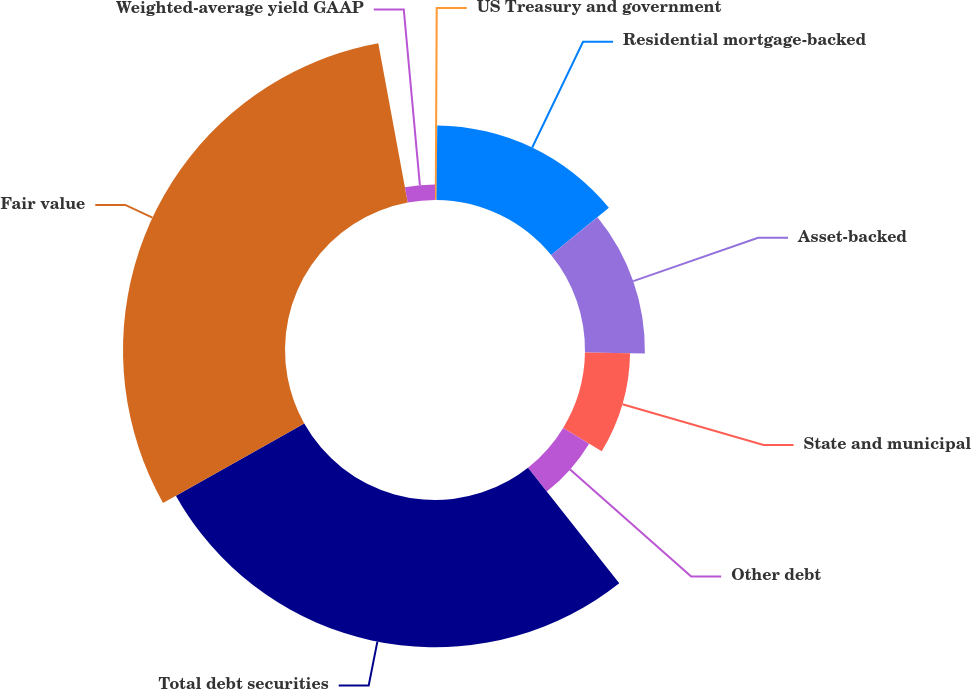Convert chart. <chart><loc_0><loc_0><loc_500><loc_500><pie_chart><fcel>US Treasury and government<fcel>Residential mortgage-backed<fcel>Asset-backed<fcel>State and municipal<fcel>Other debt<fcel>Total debt securities<fcel>Fair value<fcel>Weighted-average yield GAAP<nl><fcel>0.16%<fcel>13.93%<fcel>11.18%<fcel>8.42%<fcel>5.67%<fcel>27.49%<fcel>30.24%<fcel>2.91%<nl></chart> 